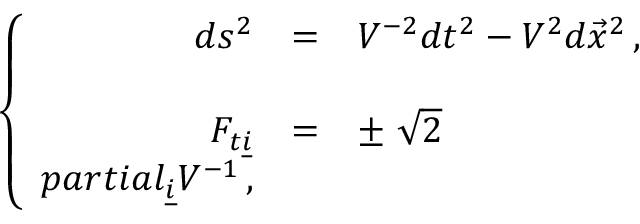Convert formula to latex. <formula><loc_0><loc_0><loc_500><loc_500>\left \{ \begin{array} { r c l } { { d s ^ { 2 } } } & { = } & { { V ^ { - 2 } d t ^ { 2 } - V ^ { 2 } d \vec { x } ^ { 2 } \, , } } \\ { { F _ { t \underline { i } } } } & { = } & { { \pm \ \sqrt { 2 } } } \\ { { p a r t i a l _ { \underline { i } } V ^ { - 1 } \, , } } \end{array}</formula> 